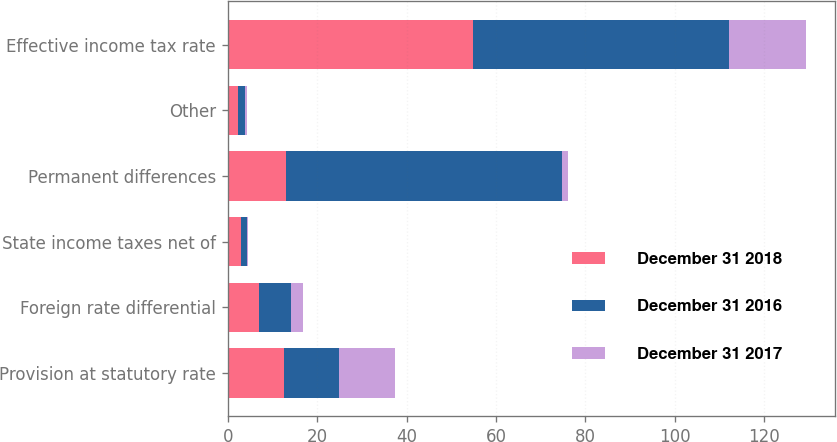Convert chart to OTSL. <chart><loc_0><loc_0><loc_500><loc_500><stacked_bar_chart><ecel><fcel>Provision at statutory rate<fcel>Foreign rate differential<fcel>State income taxes net of<fcel>Permanent differences<fcel>Other<fcel>Effective income tax rate<nl><fcel>December 31 2018<fcel>12.5<fcel>7.1<fcel>3<fcel>13<fcel>2.3<fcel>54.9<nl><fcel>December 31 2016<fcel>12.5<fcel>7.1<fcel>1.4<fcel>61.8<fcel>1.6<fcel>57.3<nl><fcel>December 31 2017<fcel>12.5<fcel>2.6<fcel>0.1<fcel>1.3<fcel>0.4<fcel>17.2<nl></chart> 